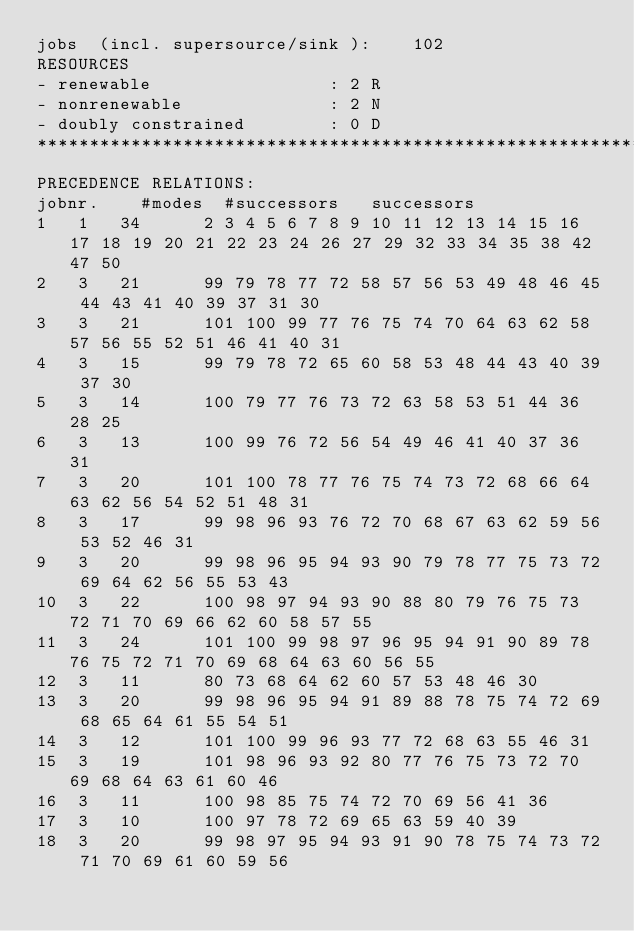<code> <loc_0><loc_0><loc_500><loc_500><_ObjectiveC_>jobs  (incl. supersource/sink ):	102
RESOURCES
- renewable                 : 2 R
- nonrenewable              : 2 N
- doubly constrained        : 0 D
************************************************************************
PRECEDENCE RELATIONS:
jobnr.    #modes  #successors   successors
1	1	34		2 3 4 5 6 7 8 9 10 11 12 13 14 15 16 17 18 19 20 21 22 23 24 26 27 29 32 33 34 35 38 42 47 50 
2	3	21		99 79 78 77 72 58 57 56 53 49 48 46 45 44 43 41 40 39 37 31 30 
3	3	21		101 100 99 77 76 75 74 70 64 63 62 58 57 56 55 52 51 46 41 40 31 
4	3	15		99 79 78 72 65 60 58 53 48 44 43 40 39 37 30 
5	3	14		100 79 77 76 73 72 63 58 53 51 44 36 28 25 
6	3	13		100 99 76 72 56 54 49 46 41 40 37 36 31 
7	3	20		101 100 78 77 76 75 74 73 72 68 66 64 63 62 56 54 52 51 48 31 
8	3	17		99 98 96 93 76 72 70 68 67 63 62 59 56 53 52 46 31 
9	3	20		99 98 96 95 94 93 90 79 78 77 75 73 72 69 64 62 56 55 53 43 
10	3	22		100 98 97 94 93 90 88 80 79 76 75 73 72 71 70 69 66 62 60 58 57 55 
11	3	24		101 100 99 98 97 96 95 94 91 90 89 78 76 75 72 71 70 69 68 64 63 60 56 55 
12	3	11		80 73 68 64 62 60 57 53 48 46 30 
13	3	20		99 98 96 95 94 91 89 88 78 75 74 72 69 68 65 64 61 55 54 51 
14	3	12		101 100 99 96 93 77 72 68 63 55 46 31 
15	3	19		101 98 96 93 92 80 77 76 75 73 72 70 69 68 64 63 61 60 46 
16	3	11		100 98 85 75 74 72 70 69 56 41 36 
17	3	10		100 97 78 72 69 65 63 59 40 39 
18	3	20		99 98 97 95 94 93 91 90 78 75 74 73 72 71 70 69 61 60 59 56 </code> 